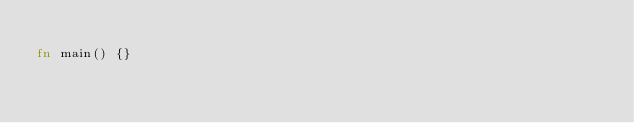Convert code to text. <code><loc_0><loc_0><loc_500><loc_500><_Rust_>
fn main() {}
</code> 